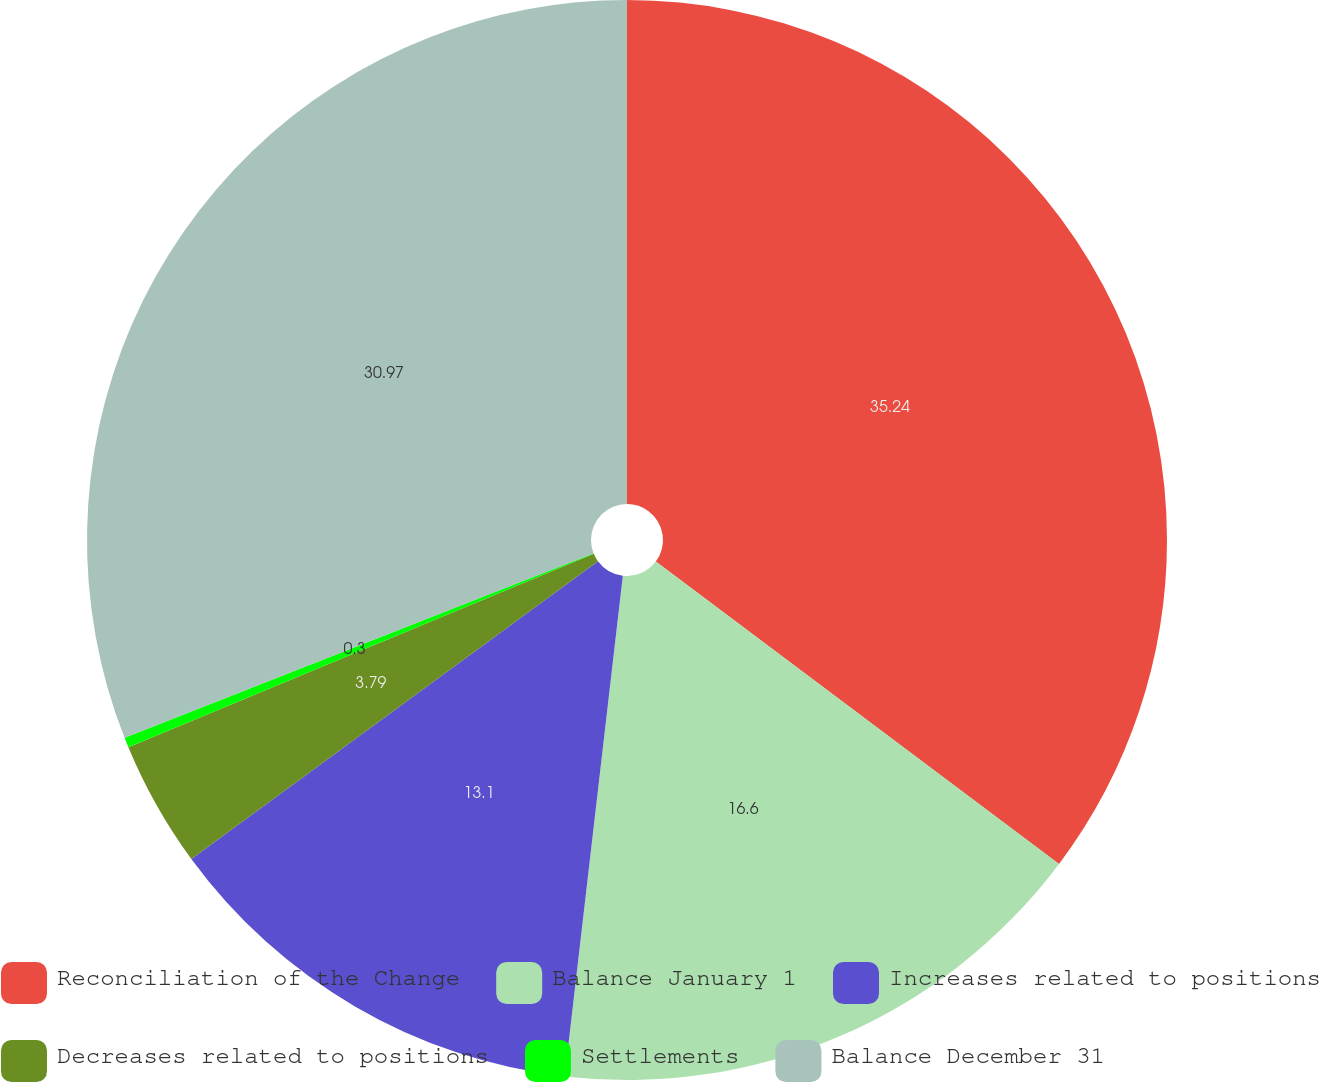<chart> <loc_0><loc_0><loc_500><loc_500><pie_chart><fcel>Reconciliation of the Change<fcel>Balance January 1<fcel>Increases related to positions<fcel>Decreases related to positions<fcel>Settlements<fcel>Balance December 31<nl><fcel>35.24%<fcel>16.6%<fcel>13.1%<fcel>3.79%<fcel>0.3%<fcel>30.97%<nl></chart> 